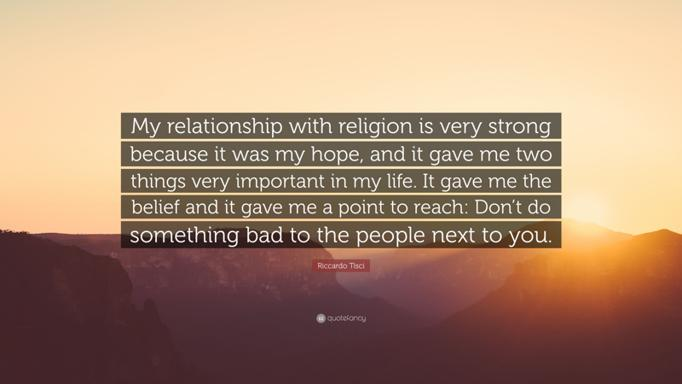What can we infer about Riccardo Tisci from the quote? From Riccardo Tisci's words, we can infer that his profound relationship with religion not only offers him personal solace and a framework for hope but also inspires him to interact with kindness and compassion towards others. His faith clearly plays a crucial role in shaping his ethical viewpoints and his approach to social interactions. 